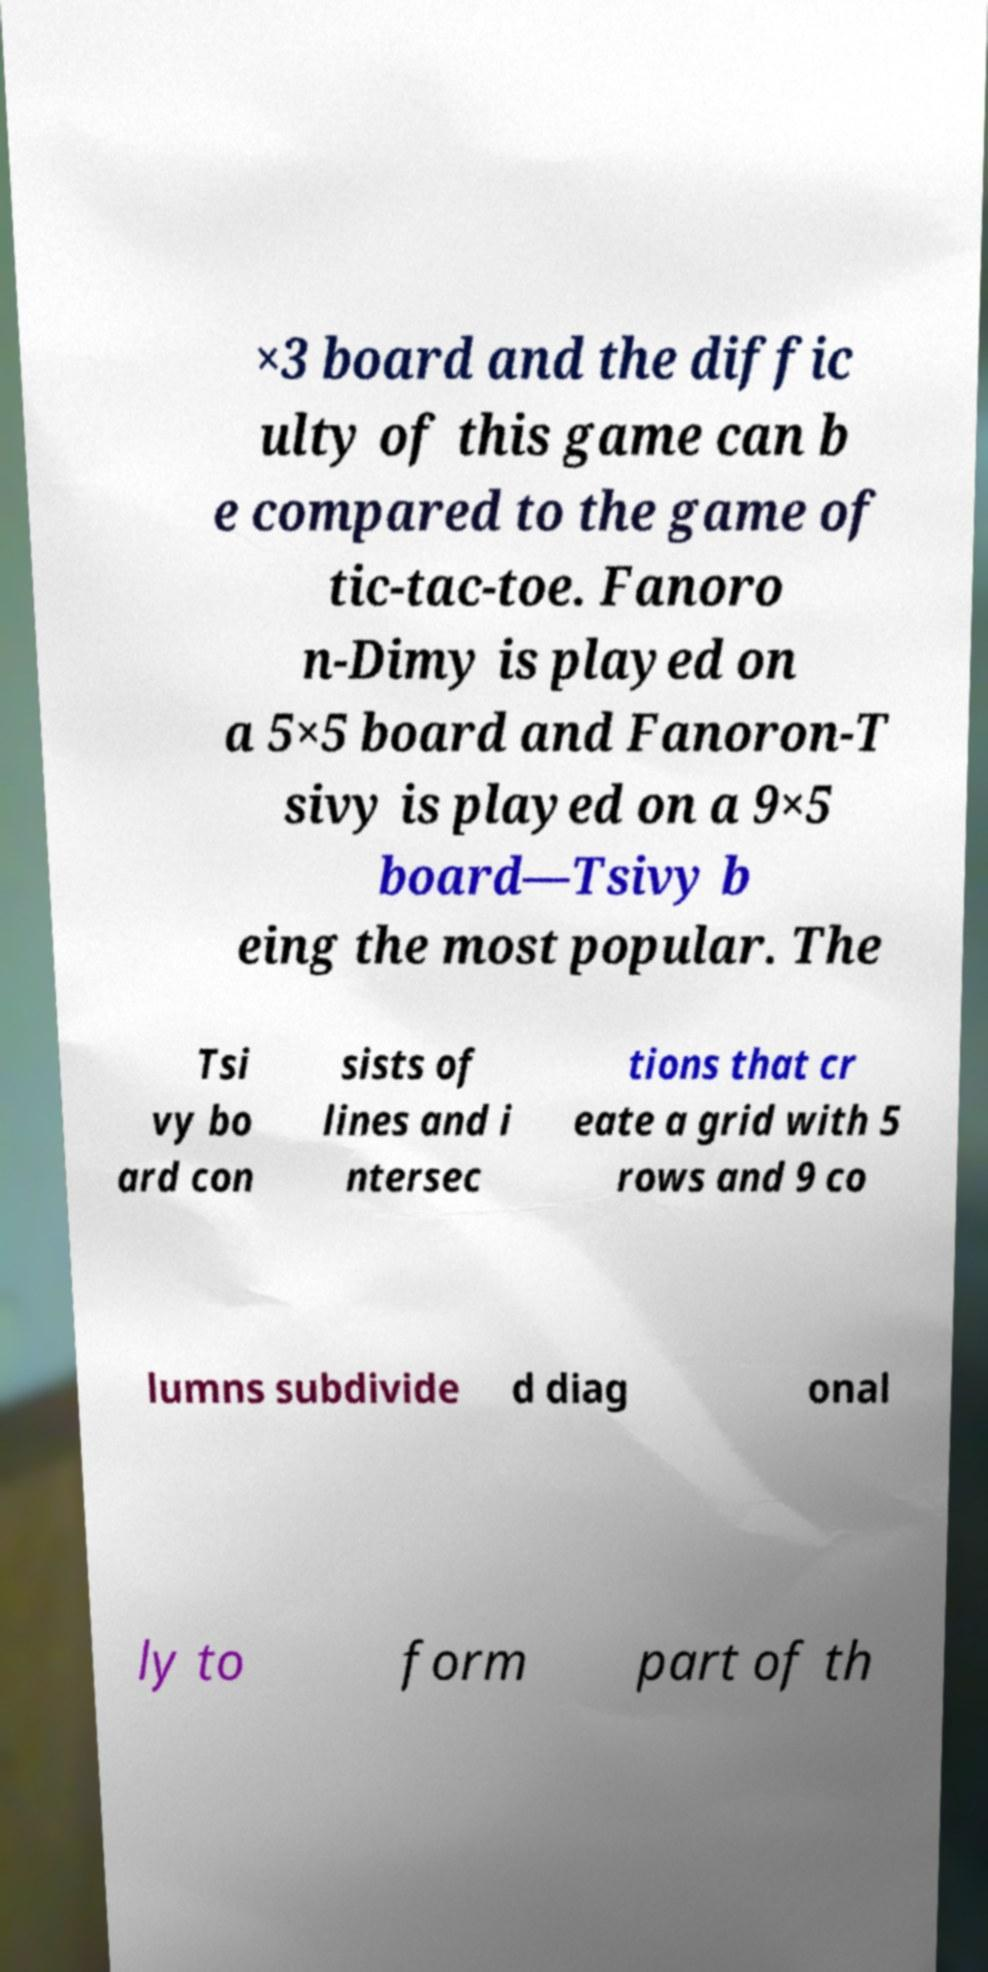There's text embedded in this image that I need extracted. Can you transcribe it verbatim? ×3 board and the diffic ulty of this game can b e compared to the game of tic-tac-toe. Fanoro n-Dimy is played on a 5×5 board and Fanoron-T sivy is played on a 9×5 board—Tsivy b eing the most popular. The Tsi vy bo ard con sists of lines and i ntersec tions that cr eate a grid with 5 rows and 9 co lumns subdivide d diag onal ly to form part of th 